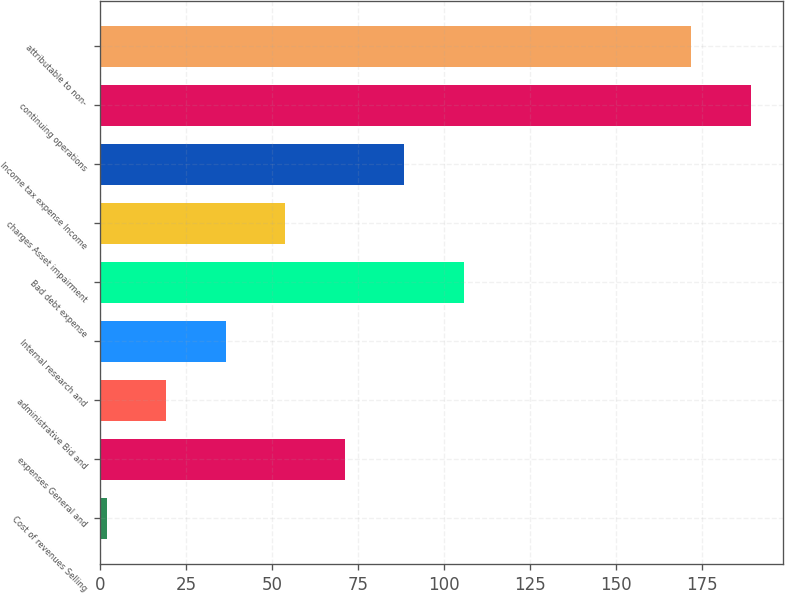<chart> <loc_0><loc_0><loc_500><loc_500><bar_chart><fcel>Cost of revenues Selling<fcel>expenses General and<fcel>administrative Bid and<fcel>Internal research and<fcel>Bad debt expense<fcel>charges Asset impairment<fcel>Income tax expense Income<fcel>continuing operations<fcel>attributable to non-<nl><fcel>2<fcel>71.2<fcel>19.3<fcel>36.6<fcel>105.8<fcel>53.9<fcel>88.5<fcel>189.3<fcel>172<nl></chart> 